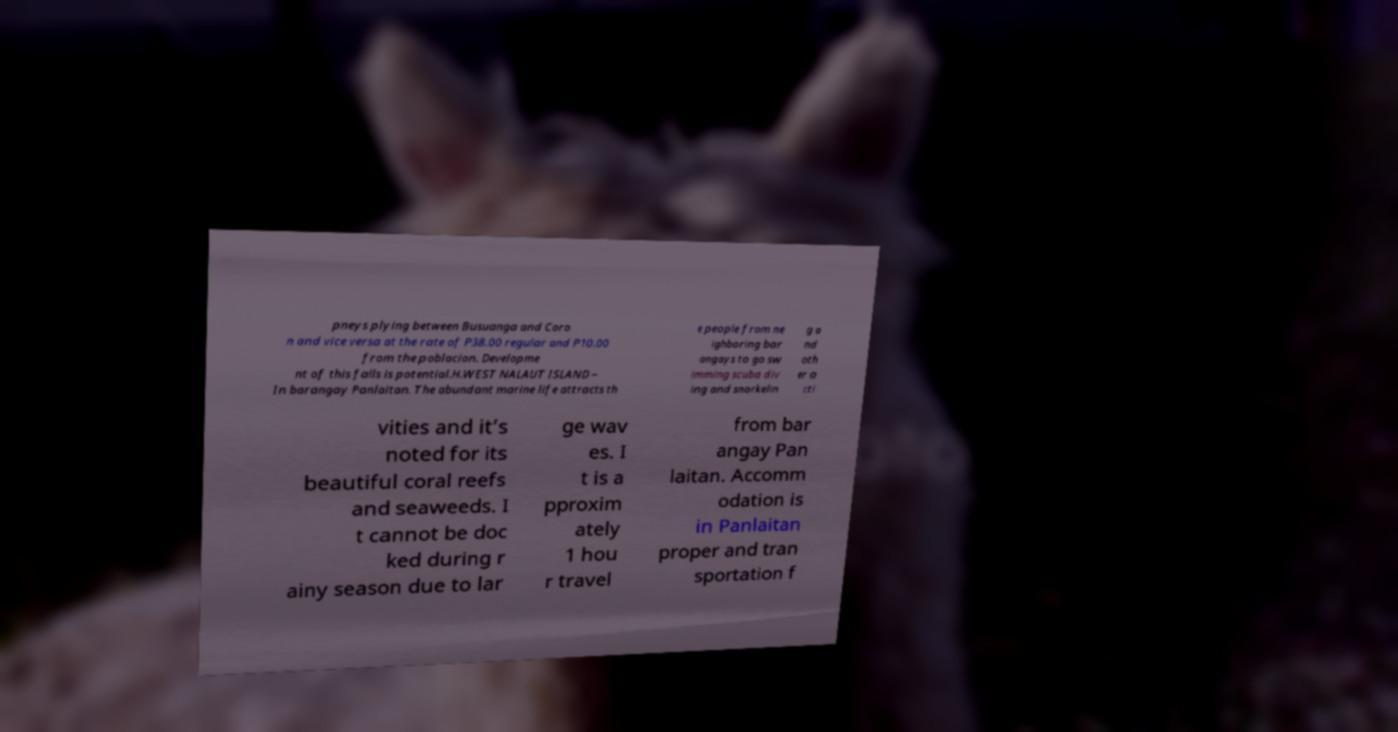I need the written content from this picture converted into text. Can you do that? pneys plying between Busuanga and Coro n and vice versa at the rate of P38.00 regular and P10.00 from the poblacion. Developme nt of this falls is potential.H.WEST NALAUT ISLAND – In barangay Panlaitan. The abundant marine life attracts th e people from ne ighboring bar angays to go sw imming scuba div ing and snorkelin g a nd oth er a cti vities and it’s noted for its beautiful coral reefs and seaweeds. I t cannot be doc ked during r ainy season due to lar ge wav es. I t is a pproxim ately 1 hou r travel from bar angay Pan laitan. Accomm odation is in Panlaitan proper and tran sportation f 